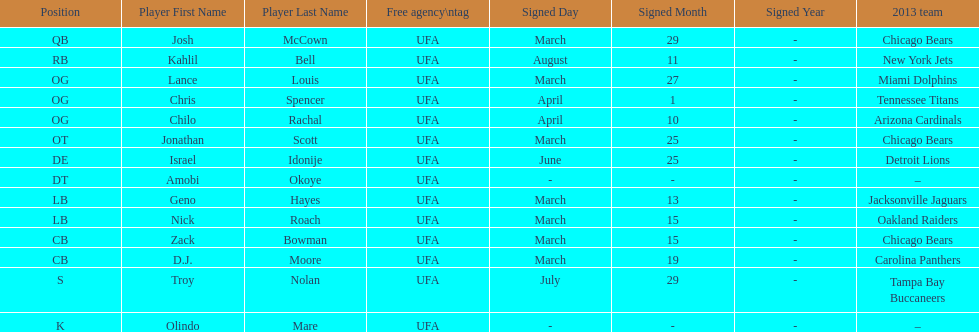Signed the same date as "april fools day". Chris Spencer. 